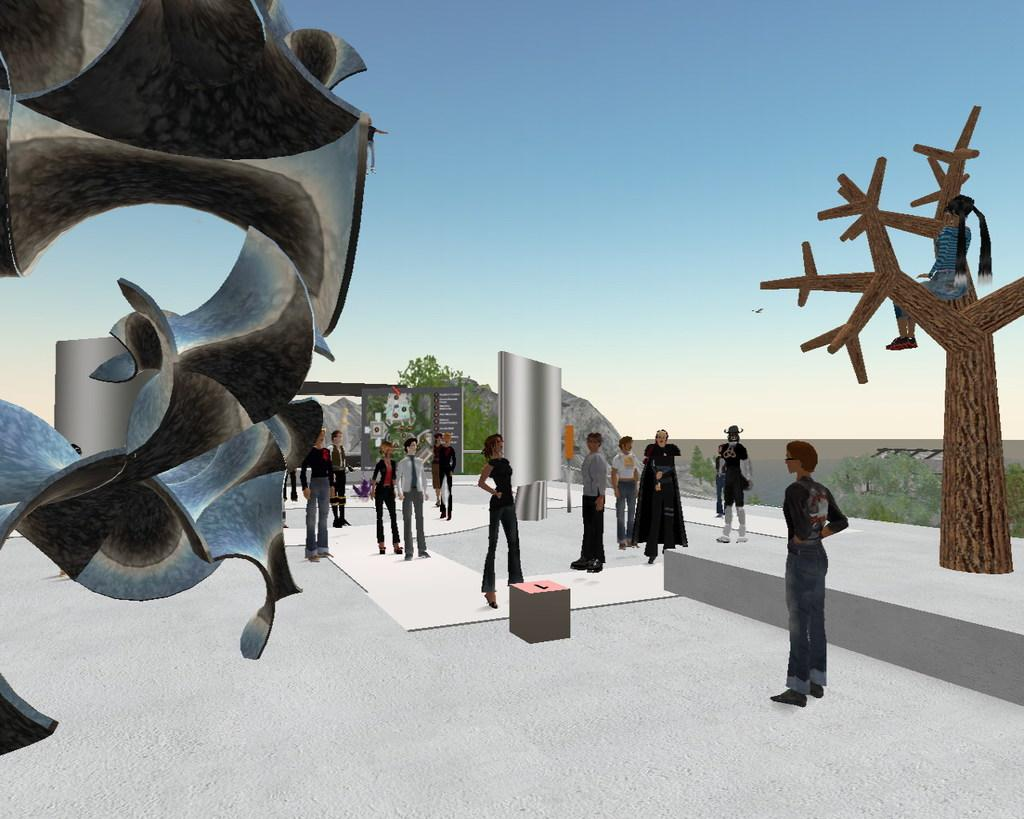How many people are in the image? There are persons standing in the image. What type of natural elements can be seen in the image? There are trees in the image. What colors are present in the objects in the image? There are objects with silver and brown colors in the image. Is the sea visible in the image? No, the sea is not visible in the image. Is it raining in the image? There is no indication of rain in the image. 